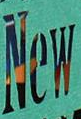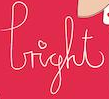What words can you see in these images in sequence, separated by a semicolon? New; light 